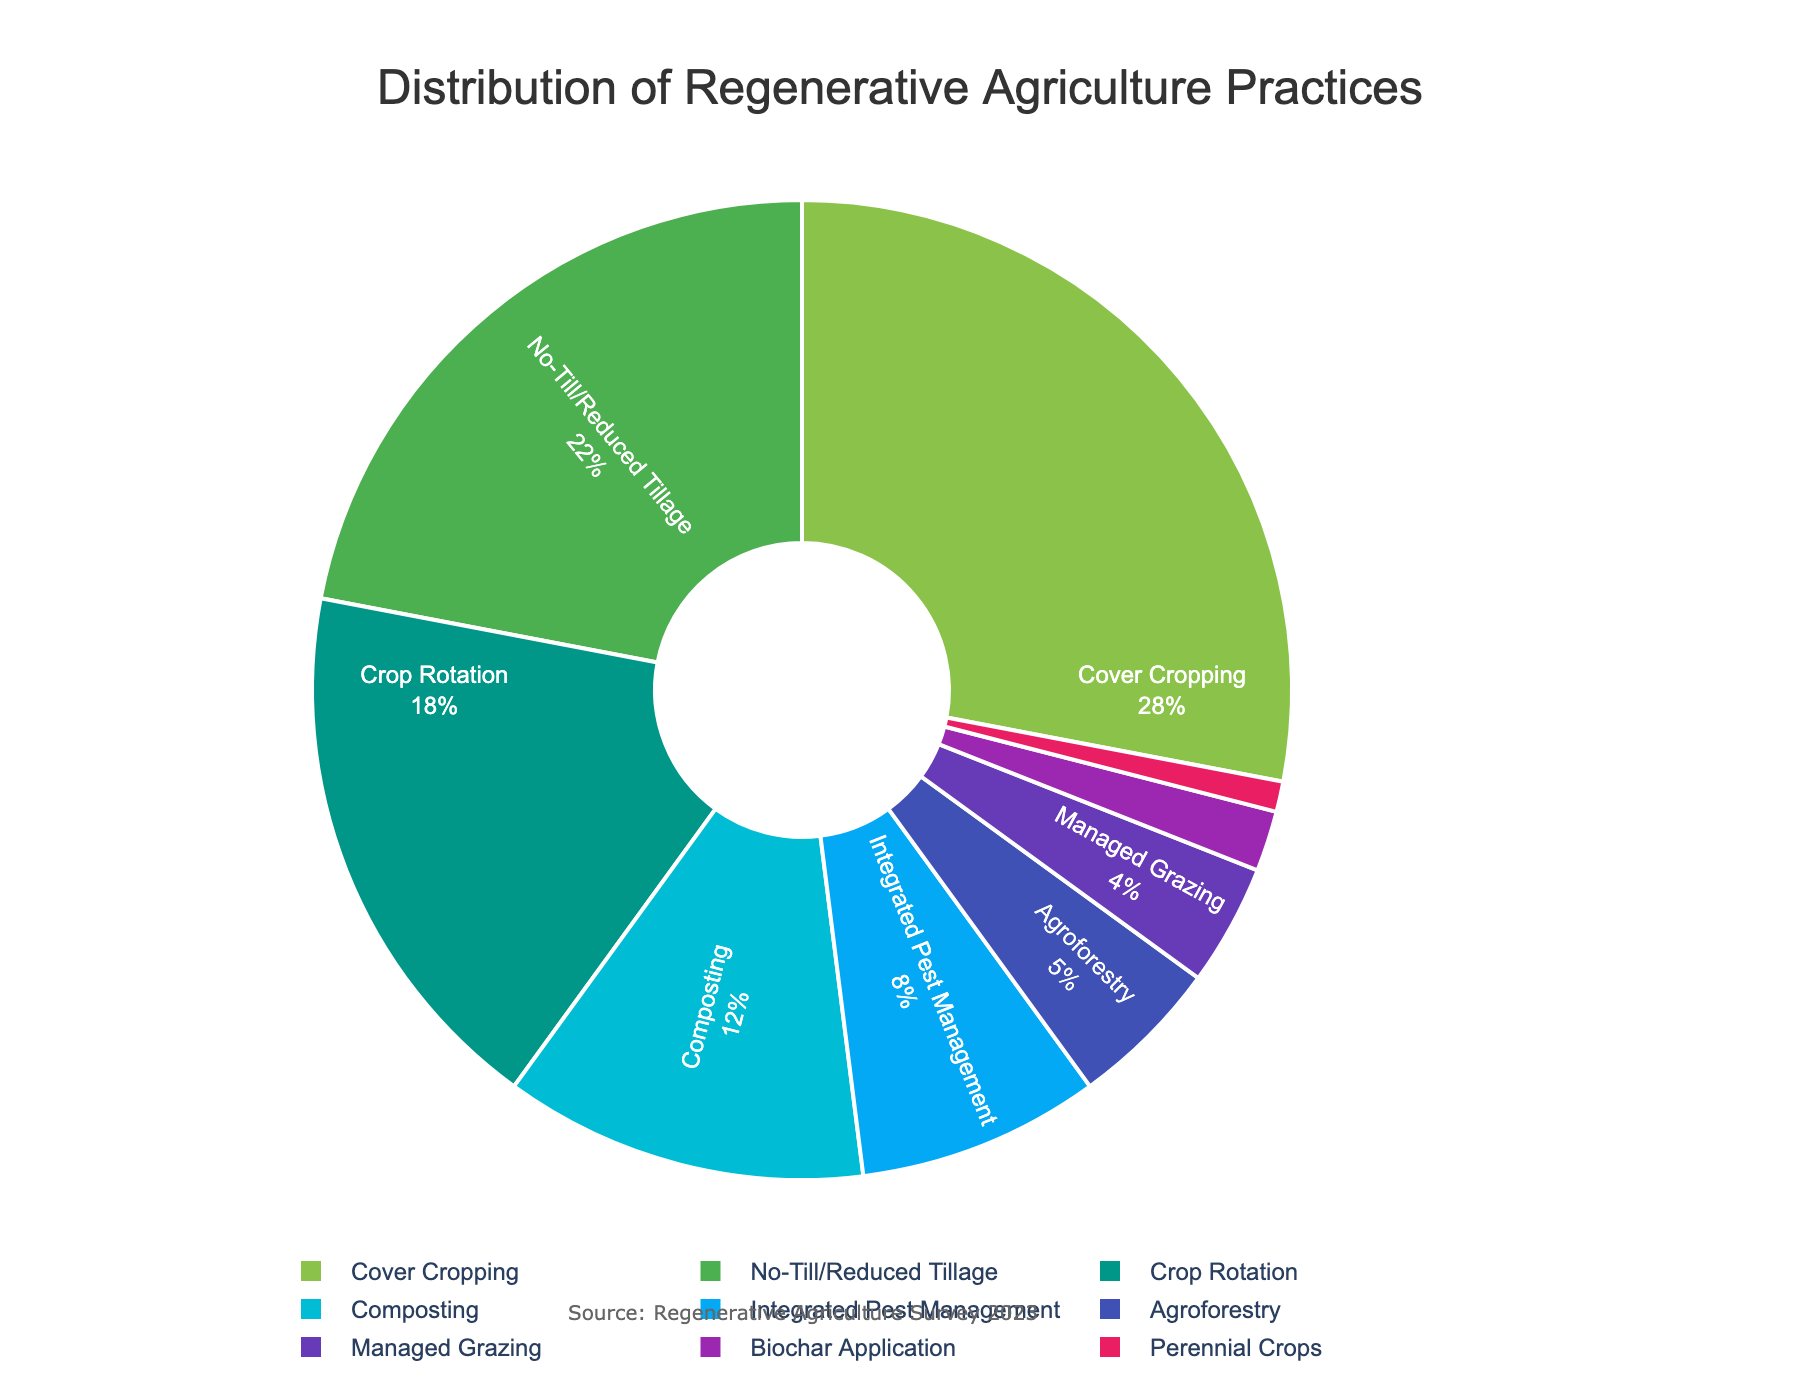What is the most common regenerative agriculture practice among farmers? The largest segment in the pie chart is "Cover Cropping," which occupies the greatest portion of the chart. Therefore, "Cover Cropping" is the most common practice.
Answer: Cover Cropping Which practice is less common: Composting or Integrated Pest Management? By comparing the sizes of the segments labeled "Composting" and "Integrated Pest Management," we see that "Composting" has a larger segment (12%) compared to "Integrated Pest Management" (8%), indicating that "Integrated Pest Management" is less common.
Answer: Integrated Pest Management What is the combined percentage of farmers using No-Till/Reduced Tillage and Crop Rotation? The percentage for No-Till/Reduced Tillage is 22% and for Crop Rotation is 18%. Adding these together gives 22% + 18% = 40%.
Answer: 40% Which practice has the smallest representation in the pie chart? The smallest segment in the pie chart is labeled "Perennial Crops," which has a percentage of 1%.
Answer: Perennial Crops How does the percentage of farmers using Managed Grazing compare to those using Biochar Application? The segment for Managed Grazing is larger than that for Biochar Application, with Managed Grazing at 4% and Biochar Application at 2%. Therefore, Managed Grazing is more common.
Answer: Managed Grazing Are there more farmers using Agroforestry or Composting? Comparing the segments for Agroforestry and Composting, we see that Composting (12%) has a larger segment than Agroforestry (5%), indicating more farmers use Composting.
Answer: Composting What percentage of farmers are using practices other than Cover Cropping, No-Till/Reduced Tillage, and Crop Rotation? Adding the percentages for Cover Cropping (28%), No-Till/Reduced Tillage (22%), and Crop Rotation (18%) gives us 68%. Subtracting this from 100% gives the percentage for other practices: 100% - 68% = 32%.
Answer: 32% What is the average percentage of the three least common practices? The percentages for the three least common practices are: Biochar Application (2%), Perennial Crops (1%), and Managed Grazing (4%). Adding these together gives 2% + 1% + 4% = 7%. Dividing by 3 gives the average: 7% / 3 = 2.33%.
Answer: 2.33% Which color segment represents Crop Rotation? By referring to the pie chart, the segment labeled "Crop Rotation" is colored with a greenish-blue hue, which is distinct from other colors used in the chart.
Answer: Greenish-blue 